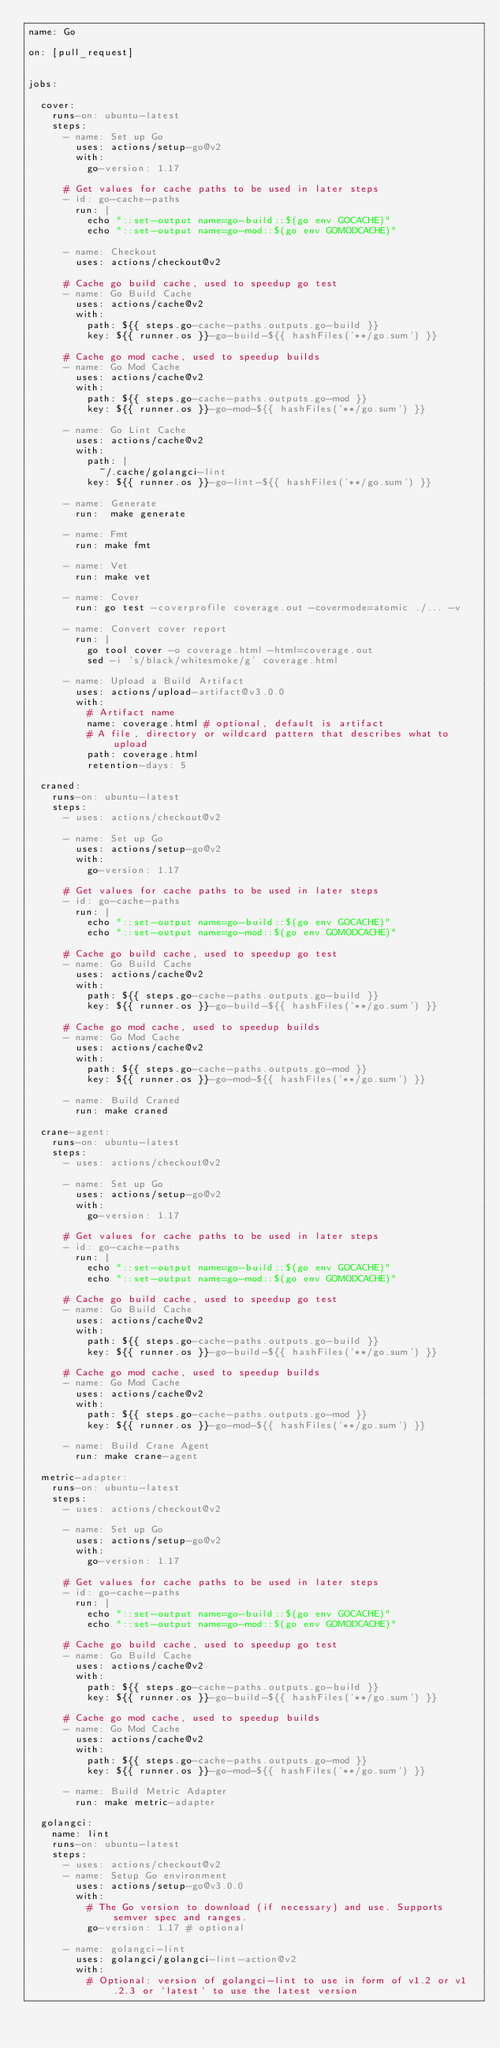<code> <loc_0><loc_0><loc_500><loc_500><_YAML_>name: Go

on: [pull_request]


jobs:

  cover:
    runs-on: ubuntu-latest
    steps:
      - name: Set up Go
        uses: actions/setup-go@v2
        with:
          go-version: 1.17
          
      # Get values for cache paths to be used in later steps
      - id: go-cache-paths
        run: |
          echo "::set-output name=go-build::$(go env GOCACHE)"
          echo "::set-output name=go-mod::$(go env GOMODCACHE)"

      - name: Checkout
        uses: actions/checkout@v2

      # Cache go build cache, used to speedup go test
      - name: Go Build Cache
        uses: actions/cache@v2
        with:
          path: ${{ steps.go-cache-paths.outputs.go-build }}
          key: ${{ runner.os }}-go-build-${{ hashFiles('**/go.sum') }}

      # Cache go mod cache, used to speedup builds
      - name: Go Mod Cache
        uses: actions/cache@v2
        with:
          path: ${{ steps.go-cache-paths.outputs.go-mod }}
          key: ${{ runner.os }}-go-mod-${{ hashFiles('**/go.sum') }}
      
      - name: Go Lint Cache
        uses: actions/cache@v2
        with:
          path: |
            ~/.cache/golangci-lint
          key: ${{ runner.os }}-go-lint-${{ hashFiles('**/go.sum') }}

      - name: Generate
        run:  make generate

      - name: Fmt
        run: make fmt
      
      - name: Vet
        run: make vet
      
      - name: Cover
        run: go test -coverprofile coverage.out -covermode=atomic ./... -v

      - name: Convert cover report
        run: |
          go tool cover -o coverage.html -html=coverage.out
          sed -i 's/black/whitesmoke/g' coverage.html
          
      - name: Upload a Build Artifact
        uses: actions/upload-artifact@v3.0.0
        with:
          # Artifact name
          name: coverage.html # optional, default is artifact
          # A file, directory or wildcard pattern that describes what to upload
          path: coverage.html
          retention-days: 5
 
  craned:
    runs-on: ubuntu-latest
    steps:
      - uses: actions/checkout@v2

      - name: Set up Go
        uses: actions/setup-go@v2
        with:
          go-version: 1.17

      # Get values for cache paths to be used in later steps
      - id: go-cache-paths
        run: |
          echo "::set-output name=go-build::$(go env GOCACHE)"
          echo "::set-output name=go-mod::$(go env GOMODCACHE)"

      # Cache go build cache, used to speedup go test
      - name: Go Build Cache
        uses: actions/cache@v2
        with:
          path: ${{ steps.go-cache-paths.outputs.go-build }}
          key: ${{ runner.os }}-go-build-${{ hashFiles('**/go.sum') }}

      # Cache go mod cache, used to speedup builds
      - name: Go Mod Cache
        uses: actions/cache@v2
        with:
          path: ${{ steps.go-cache-paths.outputs.go-mod }}
          key: ${{ runner.os }}-go-mod-${{ hashFiles('**/go.sum') }}

      - name: Build Craned
        run: make craned
        
  crane-agent:
    runs-on: ubuntu-latest
    steps:
      - uses: actions/checkout@v2

      - name: Set up Go
        uses: actions/setup-go@v2
        with:
          go-version: 1.17

      # Get values for cache paths to be used in later steps
      - id: go-cache-paths
        run: |
          echo "::set-output name=go-build::$(go env GOCACHE)"
          echo "::set-output name=go-mod::$(go env GOMODCACHE)"

      # Cache go build cache, used to speedup go test
      - name: Go Build Cache
        uses: actions/cache@v2
        with:
          path: ${{ steps.go-cache-paths.outputs.go-build }}
          key: ${{ runner.os }}-go-build-${{ hashFiles('**/go.sum') }}

      # Cache go mod cache, used to speedup builds
      - name: Go Mod Cache
        uses: actions/cache@v2
        with:
          path: ${{ steps.go-cache-paths.outputs.go-mod }}
          key: ${{ runner.os }}-go-mod-${{ hashFiles('**/go.sum') }}

      - name: Build Crane Agent
        run: make crane-agent

  metric-adapter:
    runs-on: ubuntu-latest
    steps:
      - uses: actions/checkout@v2

      - name: Set up Go
        uses: actions/setup-go@v2
        with:
          go-version: 1.17

      # Get values for cache paths to be used in later steps
      - id: go-cache-paths
        run: |
          echo "::set-output name=go-build::$(go env GOCACHE)"
          echo "::set-output name=go-mod::$(go env GOMODCACHE)"

      # Cache go build cache, used to speedup go test
      - name: Go Build Cache
        uses: actions/cache@v2
        with:
          path: ${{ steps.go-cache-paths.outputs.go-build }}
          key: ${{ runner.os }}-go-build-${{ hashFiles('**/go.sum') }}

      # Cache go mod cache, used to speedup builds
      - name: Go Mod Cache
        uses: actions/cache@v2
        with:
          path: ${{ steps.go-cache-paths.outputs.go-mod }}
          key: ${{ runner.os }}-go-mod-${{ hashFiles('**/go.sum') }}

      - name: Build Metric Adapter
        run: make metric-adapter
        
  golangci:
    name: lint
    runs-on: ubuntu-latest
    steps:
      - uses: actions/checkout@v2
      - name: Setup Go environment
        uses: actions/setup-go@v3.0.0
        with:
          # The Go version to download (if necessary) and use. Supports semver spec and ranges.
          go-version: 1.17 # optional
          
      - name: golangci-lint
        uses: golangci/golangci-lint-action@v2
        with:
          # Optional: version of golangci-lint to use in form of v1.2 or v1.2.3 or `latest` to use the latest version</code> 